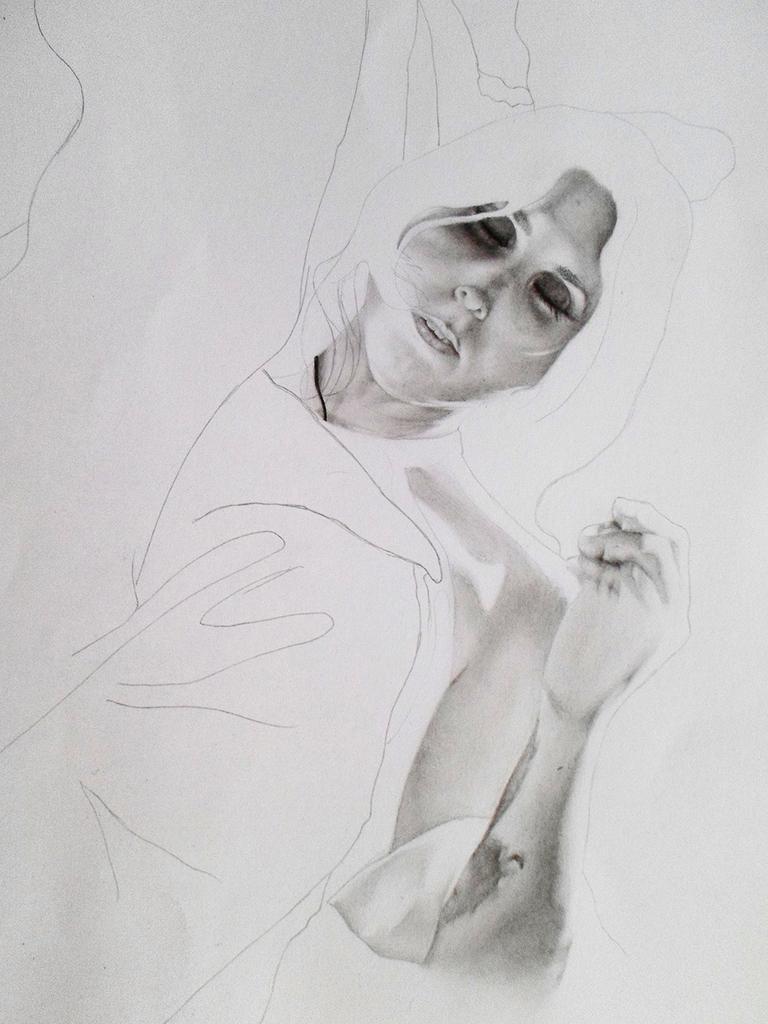In one or two sentences, can you explain what this image depicts? In this image I can see the drawing of the person on the white color paper. I can see the person's face and hand in this image. 